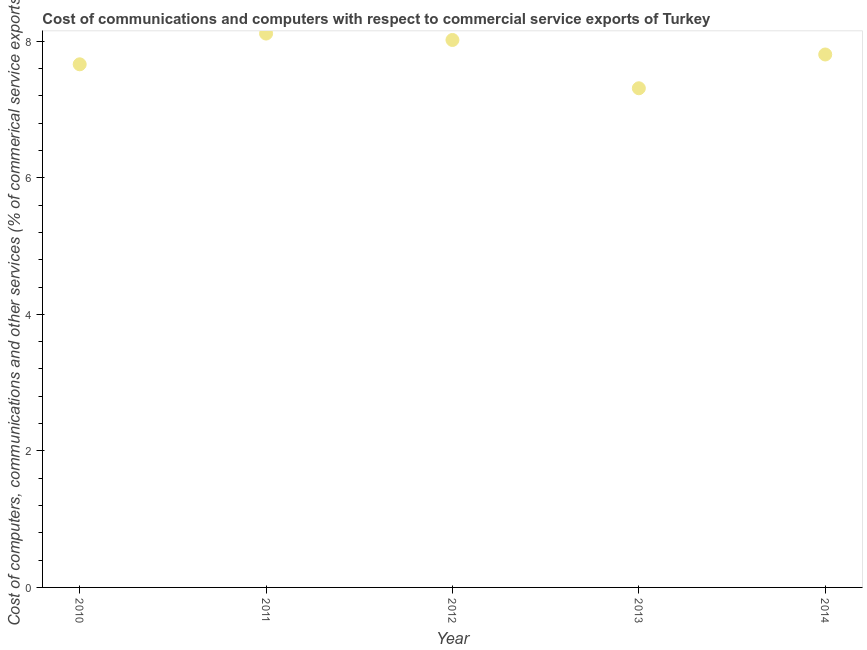What is the cost of communications in 2014?
Give a very brief answer. 7.81. Across all years, what is the maximum  computer and other services?
Make the answer very short. 8.11. Across all years, what is the minimum  computer and other services?
Provide a short and direct response. 7.31. In which year was the cost of communications maximum?
Provide a succinct answer. 2011. What is the sum of the cost of communications?
Your answer should be compact. 38.91. What is the difference between the cost of communications in 2012 and 2014?
Keep it short and to the point. 0.21. What is the average cost of communications per year?
Provide a succinct answer. 7.78. What is the median  computer and other services?
Provide a succinct answer. 7.81. Do a majority of the years between 2011 and 2010 (inclusive) have  computer and other services greater than 6 %?
Offer a very short reply. No. What is the ratio of the  computer and other services in 2010 to that in 2013?
Provide a short and direct response. 1.05. Is the difference between the cost of communications in 2010 and 2014 greater than the difference between any two years?
Give a very brief answer. No. What is the difference between the highest and the second highest cost of communications?
Your response must be concise. 0.09. Is the sum of the  computer and other services in 2010 and 2014 greater than the maximum  computer and other services across all years?
Make the answer very short. Yes. What is the difference between the highest and the lowest cost of communications?
Ensure brevity in your answer.  0.8. In how many years, is the  computer and other services greater than the average  computer and other services taken over all years?
Keep it short and to the point. 3. Does the cost of communications monotonically increase over the years?
Offer a very short reply. No. How many years are there in the graph?
Keep it short and to the point. 5. Are the values on the major ticks of Y-axis written in scientific E-notation?
Ensure brevity in your answer.  No. Does the graph contain any zero values?
Provide a succinct answer. No. Does the graph contain grids?
Ensure brevity in your answer.  No. What is the title of the graph?
Provide a succinct answer. Cost of communications and computers with respect to commercial service exports of Turkey. What is the label or title of the Y-axis?
Your response must be concise. Cost of computers, communications and other services (% of commerical service exports). What is the Cost of computers, communications and other services (% of commerical service exports) in 2010?
Offer a very short reply. 7.66. What is the Cost of computers, communications and other services (% of commerical service exports) in 2011?
Ensure brevity in your answer.  8.11. What is the Cost of computers, communications and other services (% of commerical service exports) in 2012?
Provide a succinct answer. 8.02. What is the Cost of computers, communications and other services (% of commerical service exports) in 2013?
Your answer should be very brief. 7.31. What is the Cost of computers, communications and other services (% of commerical service exports) in 2014?
Make the answer very short. 7.81. What is the difference between the Cost of computers, communications and other services (% of commerical service exports) in 2010 and 2011?
Keep it short and to the point. -0.45. What is the difference between the Cost of computers, communications and other services (% of commerical service exports) in 2010 and 2012?
Offer a very short reply. -0.36. What is the difference between the Cost of computers, communications and other services (% of commerical service exports) in 2010 and 2013?
Provide a short and direct response. 0.35. What is the difference between the Cost of computers, communications and other services (% of commerical service exports) in 2010 and 2014?
Provide a short and direct response. -0.14. What is the difference between the Cost of computers, communications and other services (% of commerical service exports) in 2011 and 2012?
Ensure brevity in your answer.  0.09. What is the difference between the Cost of computers, communications and other services (% of commerical service exports) in 2011 and 2013?
Your response must be concise. 0.8. What is the difference between the Cost of computers, communications and other services (% of commerical service exports) in 2011 and 2014?
Offer a terse response. 0.31. What is the difference between the Cost of computers, communications and other services (% of commerical service exports) in 2012 and 2013?
Give a very brief answer. 0.71. What is the difference between the Cost of computers, communications and other services (% of commerical service exports) in 2012 and 2014?
Keep it short and to the point. 0.21. What is the difference between the Cost of computers, communications and other services (% of commerical service exports) in 2013 and 2014?
Offer a terse response. -0.49. What is the ratio of the Cost of computers, communications and other services (% of commerical service exports) in 2010 to that in 2011?
Provide a succinct answer. 0.94. What is the ratio of the Cost of computers, communications and other services (% of commerical service exports) in 2010 to that in 2012?
Your response must be concise. 0.96. What is the ratio of the Cost of computers, communications and other services (% of commerical service exports) in 2010 to that in 2013?
Keep it short and to the point. 1.05. What is the ratio of the Cost of computers, communications and other services (% of commerical service exports) in 2011 to that in 2013?
Your answer should be compact. 1.11. What is the ratio of the Cost of computers, communications and other services (% of commerical service exports) in 2011 to that in 2014?
Give a very brief answer. 1.04. What is the ratio of the Cost of computers, communications and other services (% of commerical service exports) in 2012 to that in 2013?
Offer a terse response. 1.1. What is the ratio of the Cost of computers, communications and other services (% of commerical service exports) in 2013 to that in 2014?
Offer a terse response. 0.94. 